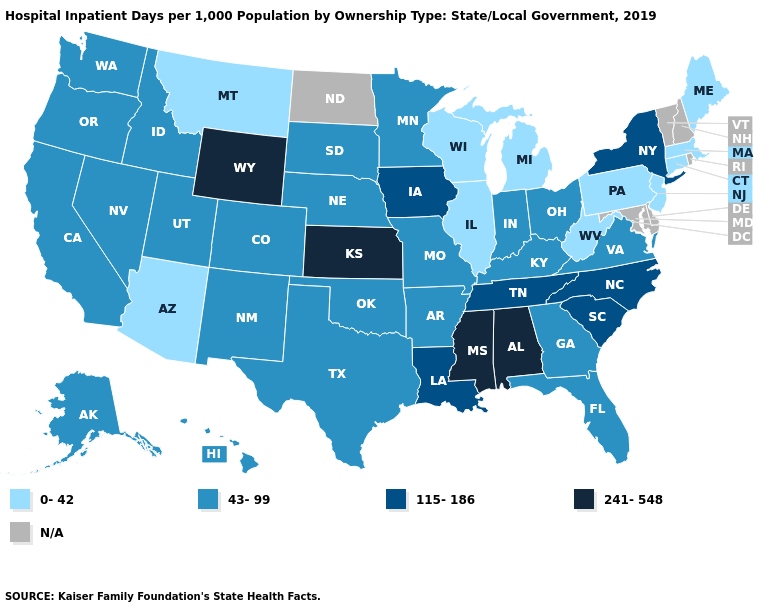Does Montana have the lowest value in the West?
Answer briefly. Yes. Which states have the highest value in the USA?
Quick response, please. Alabama, Kansas, Mississippi, Wyoming. What is the value of Mississippi?
Short answer required. 241-548. What is the value of West Virginia?
Short answer required. 0-42. What is the lowest value in the West?
Short answer required. 0-42. Name the states that have a value in the range 115-186?
Keep it brief. Iowa, Louisiana, New York, North Carolina, South Carolina, Tennessee. Which states hav the highest value in the Northeast?
Give a very brief answer. New York. Which states have the lowest value in the Northeast?
Answer briefly. Connecticut, Maine, Massachusetts, New Jersey, Pennsylvania. What is the value of South Carolina?
Give a very brief answer. 115-186. Does Pennsylvania have the lowest value in the USA?
Short answer required. Yes. Does Montana have the highest value in the USA?
Short answer required. No. What is the value of California?
Be succinct. 43-99. What is the value of Massachusetts?
Short answer required. 0-42. What is the value of Florida?
Keep it brief. 43-99. Does Ohio have the lowest value in the USA?
Concise answer only. No. 